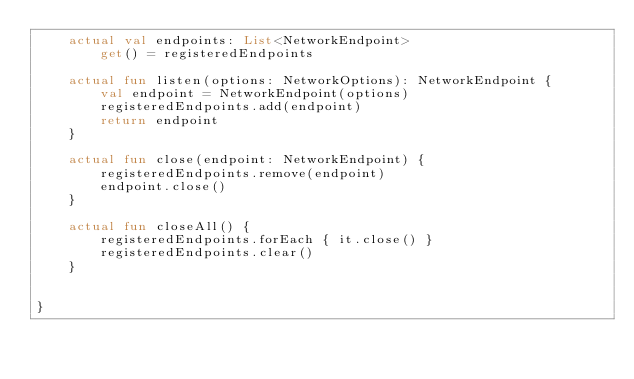Convert code to text. <code><loc_0><loc_0><loc_500><loc_500><_Kotlin_>    actual val endpoints: List<NetworkEndpoint>
        get() = registeredEndpoints

    actual fun listen(options: NetworkOptions): NetworkEndpoint {
        val endpoint = NetworkEndpoint(options)
        registeredEndpoints.add(endpoint)
        return endpoint
    }

    actual fun close(endpoint: NetworkEndpoint) {
        registeredEndpoints.remove(endpoint)
        endpoint.close()
    }

    actual fun closeAll() {
        registeredEndpoints.forEach { it.close() }
        registeredEndpoints.clear()
    }


}</code> 